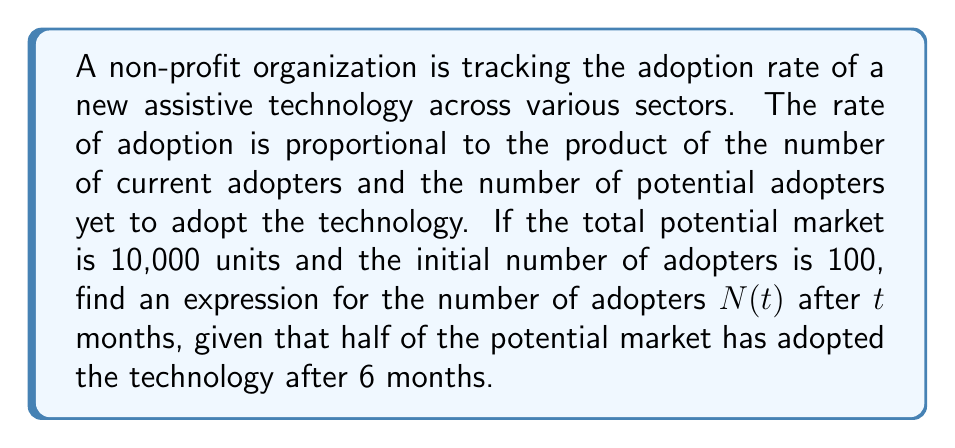Provide a solution to this math problem. Let's approach this step-by-step using a logistic growth model:

1) Let $N(t)$ be the number of adopters at time $t$, and $K = 10,000$ be the total potential market.

2) The differential equation for this scenario is:

   $$\frac{dN}{dt} = rN(K-N)$$

   where $r$ is the proportionality constant.

3) The solution to this differential equation is the logistic function:

   $$N(t) = \frac{K}{1 + Ae^{-rKt}}$$

   where $A$ is a constant to be determined.

4) At $t=0$, $N(0) = 100$. Substituting this into the equation:

   $$100 = \frac{10000}{1 + A}$$

   Solving for $A$: $A = 99$

5) We're told that half of the potential market has adopted after 6 months. This means $N(6) = 5000$:

   $$5000 = \frac{10000}{1 + 99e^{-10000r(6)}}$$

6) Solving this equation for $r$:

   $$99e^{-60000r} = 1$$
   $$e^{-60000r} = \frac{1}{99}$$
   $$-60000r = \ln(\frac{1}{99})$$
   $$r = -\frac{1}{60000}\ln(\frac{1}{99}) \approx 0.000077$$

7) Now we have all the components for our final expression:

   $$N(t) = \frac{10000}{1 + 99e^{-0.000077 \cdot 10000t}}$$

   $$N(t) = \frac{10000}{1 + 99e^{-0.77t}}$$
Answer: $$N(t) = \frac{10000}{1 + 99e^{-0.77t}}$$ 